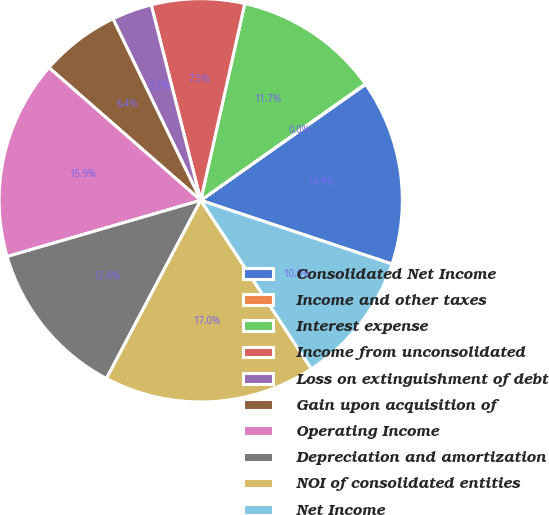<chart> <loc_0><loc_0><loc_500><loc_500><pie_chart><fcel>Consolidated Net Income<fcel>Income and other taxes<fcel>Interest expense<fcel>Income from unconsolidated<fcel>Loss on extinguishment of debt<fcel>Gain upon acquisition of<fcel>Operating Income<fcel>Depreciation and amortization<fcel>NOI of consolidated entities<fcel>Net Income<nl><fcel>14.88%<fcel>0.04%<fcel>11.7%<fcel>7.46%<fcel>3.22%<fcel>6.4%<fcel>15.94%<fcel>12.76%<fcel>17.0%<fcel>10.64%<nl></chart> 